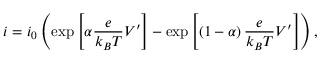Convert formula to latex. <formula><loc_0><loc_0><loc_500><loc_500>i = i _ { 0 } \left ( \exp \left [ \alpha \frac { e } { k _ { B } T } V ^ { \prime } \right ] - \exp \left [ \left ( 1 - \alpha \right ) \frac { e } { k _ { B } T } V ^ { \prime } \right ] \right ) ,</formula> 